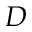Convert formula to latex. <formula><loc_0><loc_0><loc_500><loc_500>D</formula> 